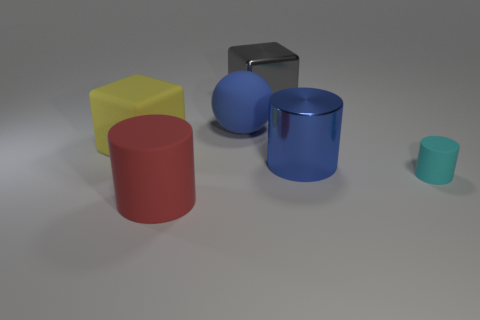Subtract all big matte cylinders. How many cylinders are left? 2 Add 4 big blue objects. How many objects exist? 10 Subtract all yellow blocks. How many blocks are left? 1 Subtract 1 cyan cylinders. How many objects are left? 5 Subtract all balls. How many objects are left? 5 Subtract 2 cylinders. How many cylinders are left? 1 Subtract all purple cylinders. Subtract all yellow spheres. How many cylinders are left? 3 Subtract all gray blocks. How many blue cylinders are left? 1 Subtract all large yellow metal cylinders. Subtract all cyan matte objects. How many objects are left? 5 Add 1 big gray objects. How many big gray objects are left? 2 